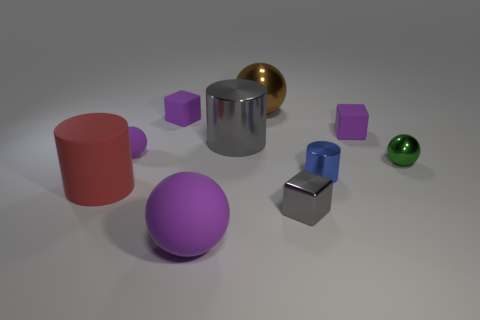Is there a purple rubber ball of the same size as the rubber cylinder?
Offer a very short reply. Yes. There is a sphere on the right side of the small block in front of the big red cylinder; what size is it?
Provide a short and direct response. Small. Is the number of spheres left of the small blue metallic cylinder less than the number of large things?
Your answer should be compact. Yes. Is the color of the large matte ball the same as the small rubber ball?
Keep it short and to the point. Yes. What is the size of the red thing?
Provide a short and direct response. Large. How many matte cylinders have the same color as the metal block?
Offer a terse response. 0. Are there any big purple rubber spheres in front of the tiny shiny object that is in front of the red cylinder on the left side of the blue thing?
Your response must be concise. Yes. There is a purple object that is the same size as the red cylinder; what is its shape?
Keep it short and to the point. Sphere. What number of big objects are either purple rubber cubes or blue things?
Provide a short and direct response. 0. The other large object that is made of the same material as the big red object is what color?
Your answer should be compact. Purple. 